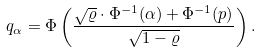<formula> <loc_0><loc_0><loc_500><loc_500>q _ { \alpha } = \Phi \left ( \frac { \sqrt { \varrho } \cdot \Phi ^ { - 1 } ( \alpha ) + \Phi ^ { - 1 } ( p ) } { \sqrt { 1 - \varrho } } \right ) .</formula> 